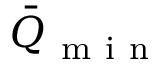<formula> <loc_0><loc_0><loc_500><loc_500>\bar { Q } _ { m i n }</formula> 